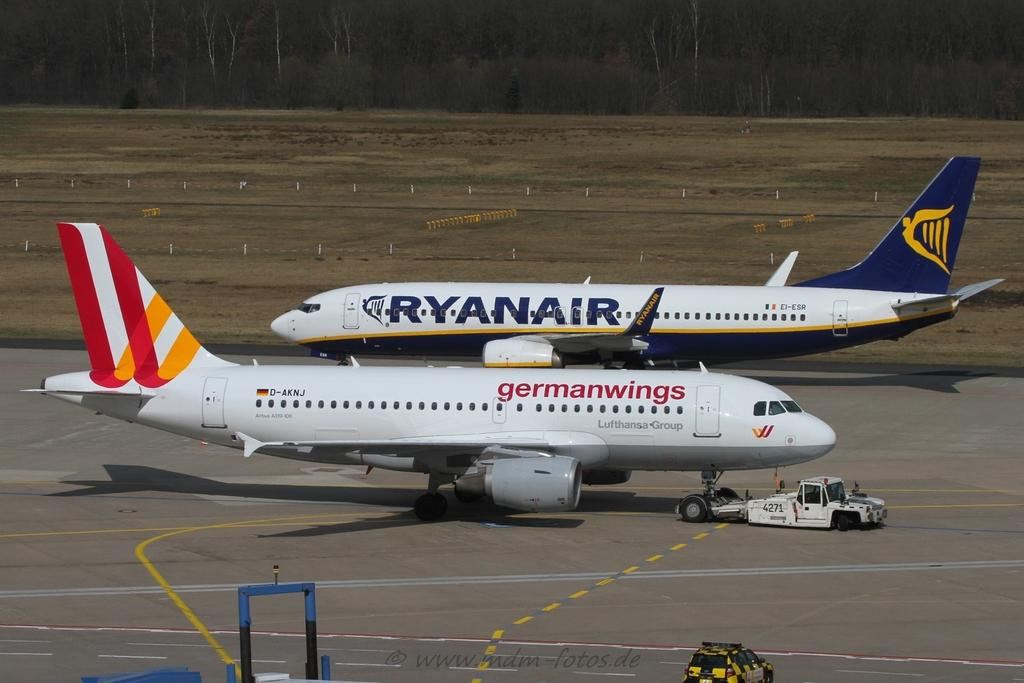<image>
Render a clear and concise summary of the photo. A German Wings plane sits in front of a Ryanair plane. 